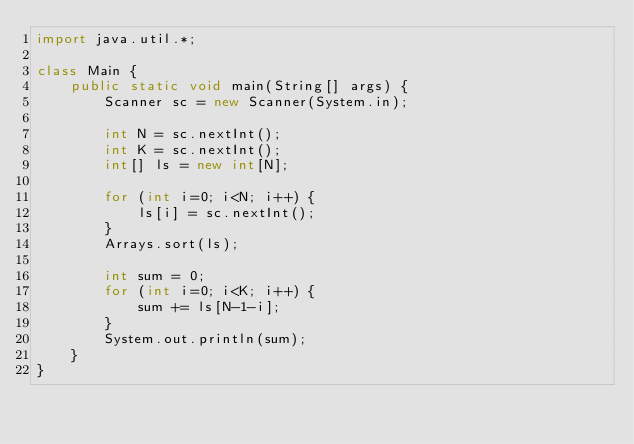Convert code to text. <code><loc_0><loc_0><loc_500><loc_500><_Java_>import java.util.*;

class Main {
    public static void main(String[] args) {
        Scanner sc = new Scanner(System.in);

        int N = sc.nextInt();
        int K = sc.nextInt();
        int[] ls = new int[N];

        for (int i=0; i<N; i++) {
            ls[i] = sc.nextInt();
        }
        Arrays.sort(ls);

        int sum = 0;
        for (int i=0; i<K; i++) {
            sum += ls[N-1-i];
        }
        System.out.println(sum);
    }
}

</code> 